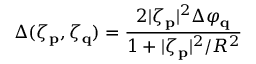<formula> <loc_0><loc_0><loc_500><loc_500>\Delta ( \zeta _ { p } , \zeta _ { q } ) = \frac { 2 | \zeta _ { p } | ^ { 2 } \Delta \varphi _ { q } } { 1 + | \zeta _ { p } | ^ { 2 } / R ^ { 2 } }</formula> 